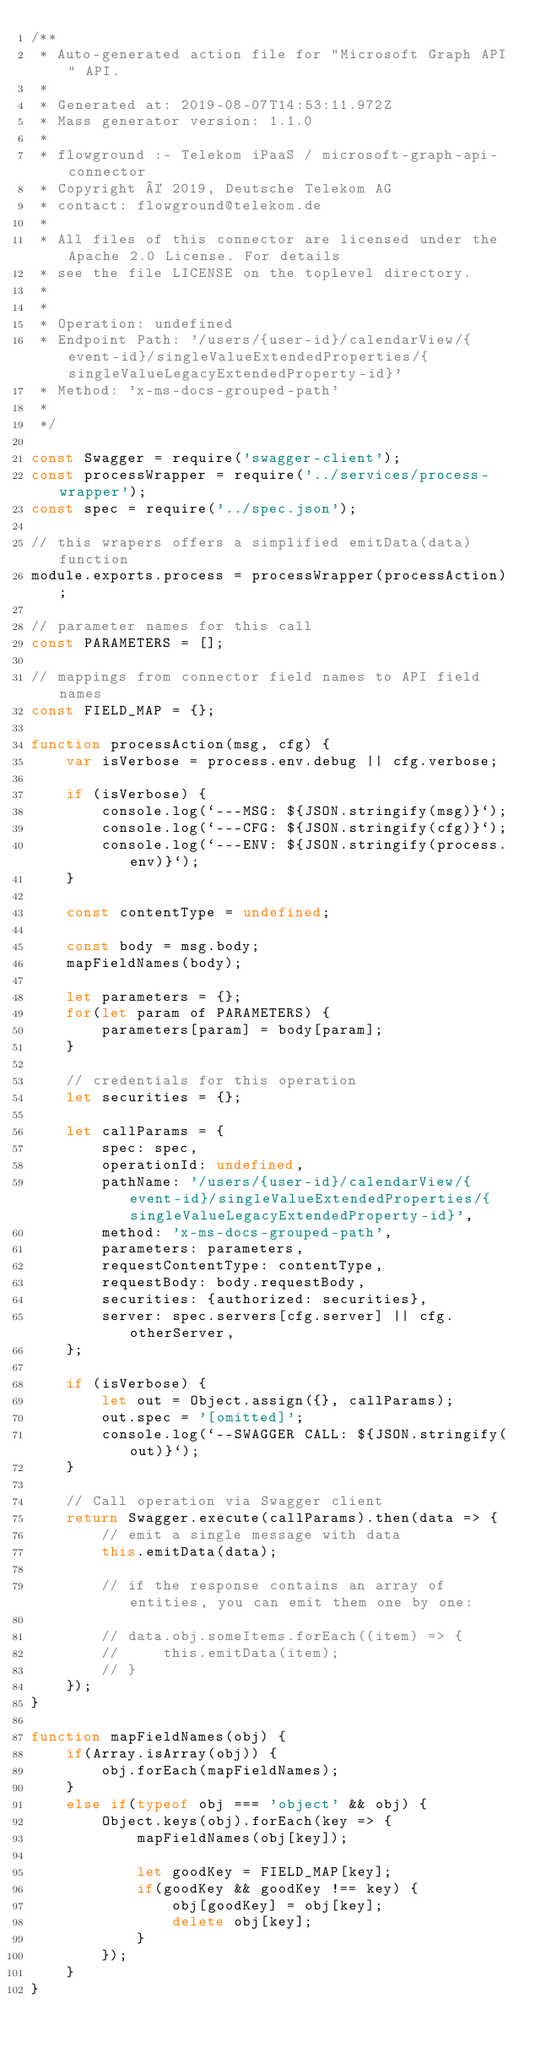Convert code to text. <code><loc_0><loc_0><loc_500><loc_500><_JavaScript_>/**
 * Auto-generated action file for "Microsoft Graph API" API.
 *
 * Generated at: 2019-08-07T14:53:11.972Z
 * Mass generator version: 1.1.0
 *
 * flowground :- Telekom iPaaS / microsoft-graph-api-connector
 * Copyright © 2019, Deutsche Telekom AG
 * contact: flowground@telekom.de
 *
 * All files of this connector are licensed under the Apache 2.0 License. For details
 * see the file LICENSE on the toplevel directory.
 *
 *
 * Operation: undefined
 * Endpoint Path: '/users/{user-id}/calendarView/{event-id}/singleValueExtendedProperties/{singleValueLegacyExtendedProperty-id}'
 * Method: 'x-ms-docs-grouped-path'
 *
 */

const Swagger = require('swagger-client');
const processWrapper = require('../services/process-wrapper');
const spec = require('../spec.json');

// this wrapers offers a simplified emitData(data) function
module.exports.process = processWrapper(processAction);

// parameter names for this call
const PARAMETERS = [];

// mappings from connector field names to API field names
const FIELD_MAP = {};

function processAction(msg, cfg) {
    var isVerbose = process.env.debug || cfg.verbose;

    if (isVerbose) {
        console.log(`---MSG: ${JSON.stringify(msg)}`);
        console.log(`---CFG: ${JSON.stringify(cfg)}`);
        console.log(`---ENV: ${JSON.stringify(process.env)}`);
    }

    const contentType = undefined;

    const body = msg.body;
    mapFieldNames(body);

    let parameters = {};
    for(let param of PARAMETERS) {
        parameters[param] = body[param];
    }

    // credentials for this operation
    let securities = {};

    let callParams = {
        spec: spec,
        operationId: undefined,
        pathName: '/users/{user-id}/calendarView/{event-id}/singleValueExtendedProperties/{singleValueLegacyExtendedProperty-id}',
        method: 'x-ms-docs-grouped-path',
        parameters: parameters,
        requestContentType: contentType,
        requestBody: body.requestBody,
        securities: {authorized: securities},
        server: spec.servers[cfg.server] || cfg.otherServer,
    };

    if (isVerbose) {
        let out = Object.assign({}, callParams);
        out.spec = '[omitted]';
        console.log(`--SWAGGER CALL: ${JSON.stringify(out)}`);
    }

    // Call operation via Swagger client
    return Swagger.execute(callParams).then(data => {
        // emit a single message with data
        this.emitData(data);

        // if the response contains an array of entities, you can emit them one by one:

        // data.obj.someItems.forEach((item) => {
        //     this.emitData(item);
        // }
    });
}

function mapFieldNames(obj) {
    if(Array.isArray(obj)) {
        obj.forEach(mapFieldNames);
    }
    else if(typeof obj === 'object' && obj) {
        Object.keys(obj).forEach(key => {
            mapFieldNames(obj[key]);

            let goodKey = FIELD_MAP[key];
            if(goodKey && goodKey !== key) {
                obj[goodKey] = obj[key];
                delete obj[key];
            }
        });
    }
}</code> 